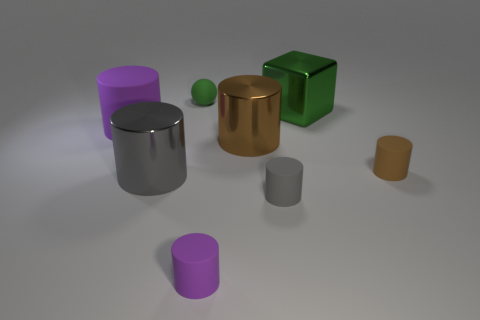There is a gray object that is to the right of the small green rubber ball; is its shape the same as the big shiny thing to the left of the ball?
Your answer should be very brief. Yes. There is a small rubber thing on the left side of the purple cylinder that is to the right of the ball; what color is it?
Keep it short and to the point. Green. What number of cylinders are either tiny brown things or green matte things?
Ensure brevity in your answer.  1. How many tiny brown things are in front of the tiny thing that is on the right side of the big shiny object that is to the right of the gray rubber thing?
Make the answer very short. 0. What size is the object that is the same color as the big matte cylinder?
Offer a very short reply. Small. Is there a large gray block that has the same material as the tiny gray thing?
Keep it short and to the point. No. Is the material of the tiny brown cylinder the same as the green sphere?
Give a very brief answer. Yes. How many purple rubber objects are behind the large metal cylinder that is to the right of the tiny rubber sphere?
Ensure brevity in your answer.  1. How many gray objects are either large cylinders or matte spheres?
Provide a short and direct response. 1. What shape is the large metallic thing behind the purple matte cylinder that is behind the small thing that is on the right side of the big green object?
Offer a terse response. Cube. 